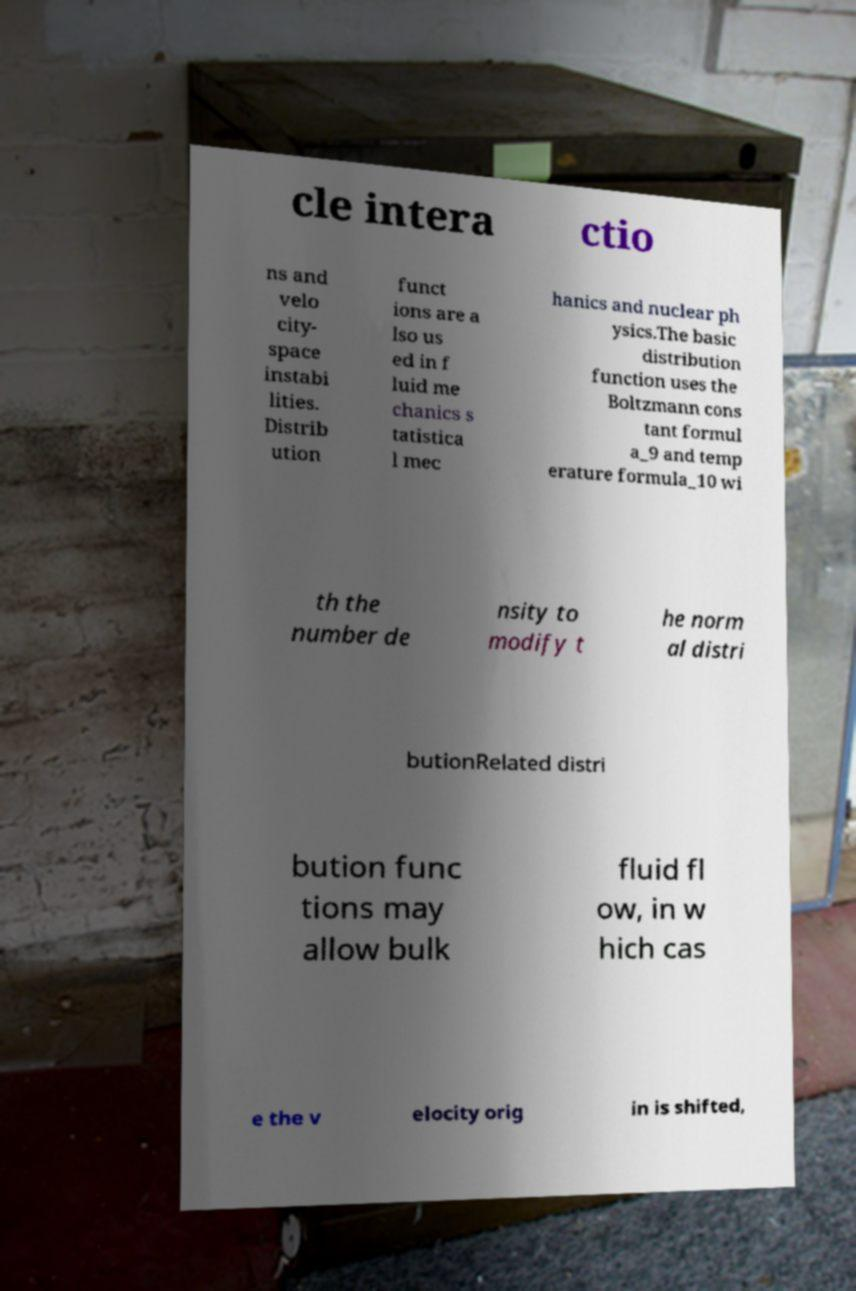Please read and relay the text visible in this image. What does it say? cle intera ctio ns and velo city- space instabi lities. Distrib ution funct ions are a lso us ed in f luid me chanics s tatistica l mec hanics and nuclear ph ysics.The basic distribution function uses the Boltzmann cons tant formul a_9 and temp erature formula_10 wi th the number de nsity to modify t he norm al distri butionRelated distri bution func tions may allow bulk fluid fl ow, in w hich cas e the v elocity orig in is shifted, 